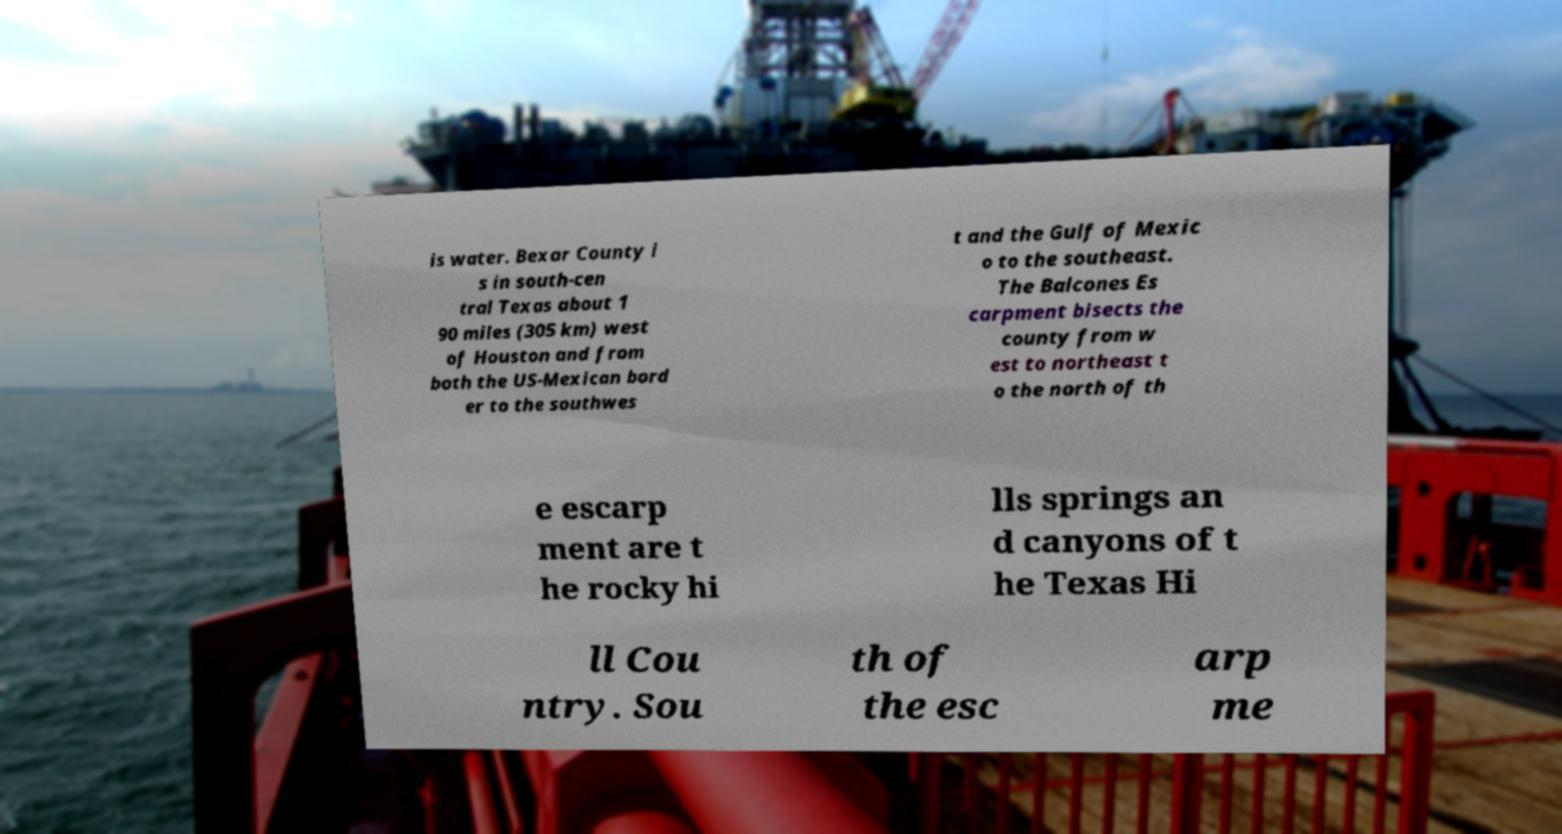Can you accurately transcribe the text from the provided image for me? is water. Bexar County i s in south-cen tral Texas about 1 90 miles (305 km) west of Houston and from both the US-Mexican bord er to the southwes t and the Gulf of Mexic o to the southeast. The Balcones Es carpment bisects the county from w est to northeast t o the north of th e escarp ment are t he rocky hi lls springs an d canyons of t he Texas Hi ll Cou ntry. Sou th of the esc arp me 